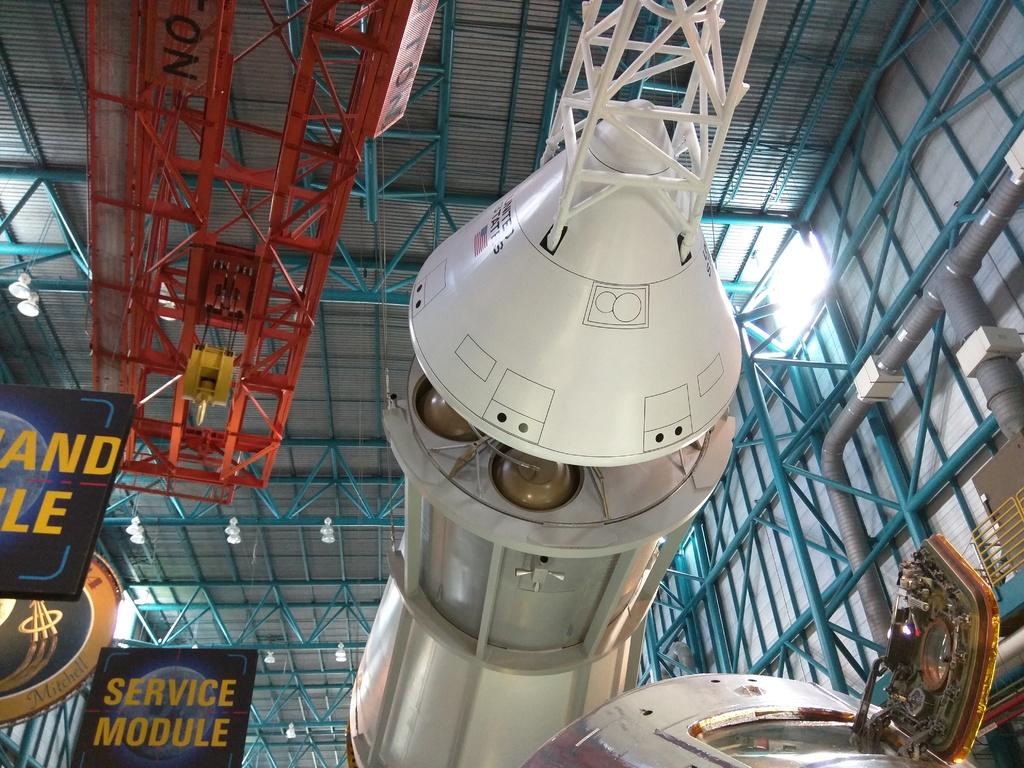What kind of module?
Provide a succinct answer. Service. What is this object called?
Your answer should be very brief. Service module. 